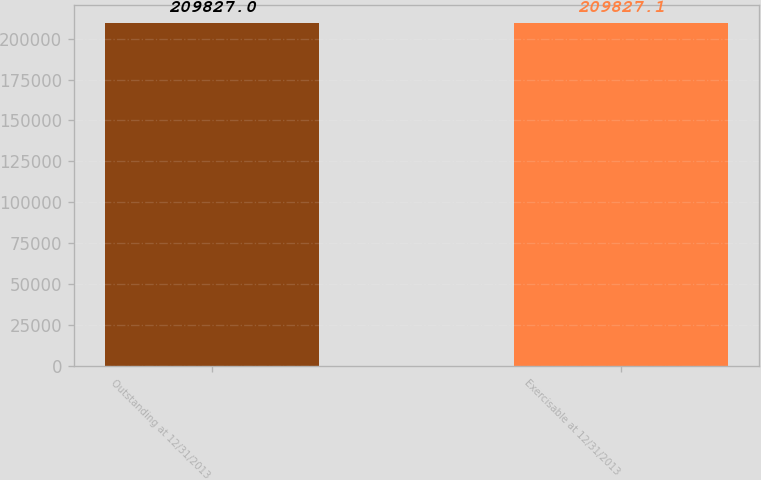<chart> <loc_0><loc_0><loc_500><loc_500><bar_chart><fcel>Outstanding at 12/31/2013<fcel>Exercisable at 12/31/2013<nl><fcel>209827<fcel>209827<nl></chart> 